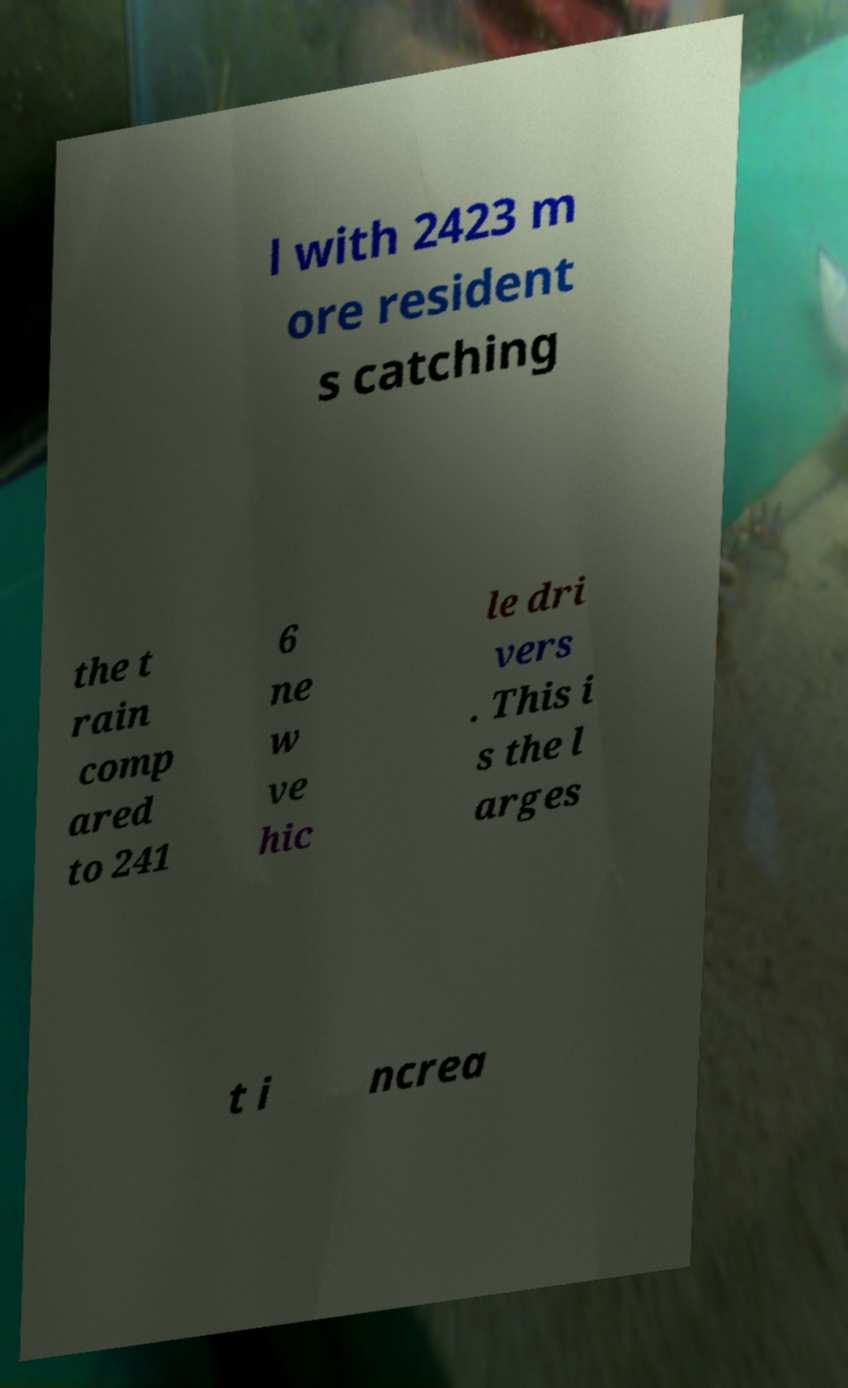Can you read and provide the text displayed in the image?This photo seems to have some interesting text. Can you extract and type it out for me? l with 2423 m ore resident s catching the t rain comp ared to 241 6 ne w ve hic le dri vers . This i s the l arges t i ncrea 